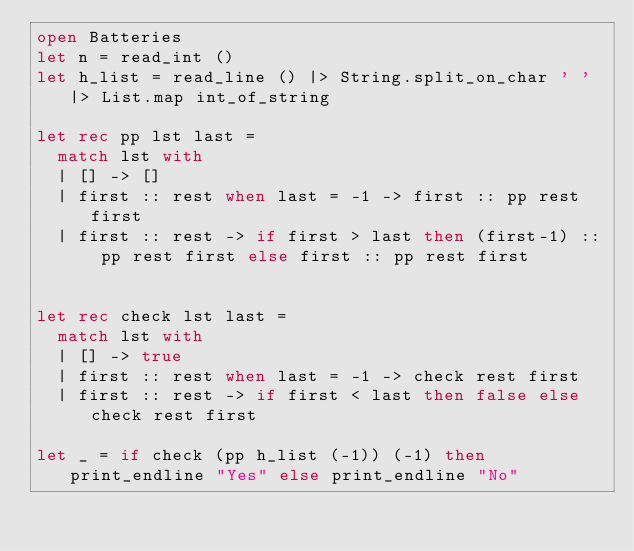<code> <loc_0><loc_0><loc_500><loc_500><_OCaml_>open Batteries
let n = read_int ()
let h_list = read_line () |> String.split_on_char ' ' |> List.map int_of_string

let rec pp lst last =
  match lst with
  | [] -> []
  | first :: rest when last = -1 -> first :: pp rest first
  | first :: rest -> if first > last then (first-1) :: pp rest first else first :: pp rest first


let rec check lst last =
  match lst with
  | [] -> true
  | first :: rest when last = -1 -> check rest first
  | first :: rest -> if first < last then false else check rest first

let _ = if check (pp h_list (-1)) (-1) then print_endline "Yes" else print_endline "No"

</code> 